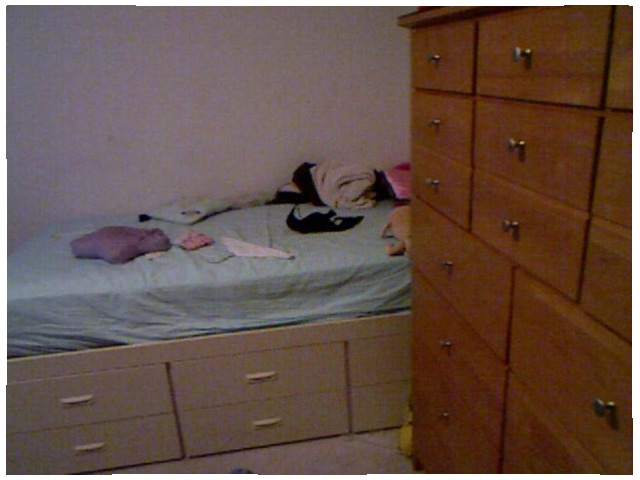<image>
Is the mattress in front of the pillow? No. The mattress is not in front of the pillow. The spatial positioning shows a different relationship between these objects. Is the clothe on the bed? Yes. Looking at the image, I can see the clothe is positioned on top of the bed, with the bed providing support. Is there a stuffed animal on the bed sheet? Yes. Looking at the image, I can see the stuffed animal is positioned on top of the bed sheet, with the bed sheet providing support. Is the clothes in the dresser? No. The clothes is not contained within the dresser. These objects have a different spatial relationship. Is there a bed behind the cupboard? Yes. From this viewpoint, the bed is positioned behind the cupboard, with the cupboard partially or fully occluding the bed. 